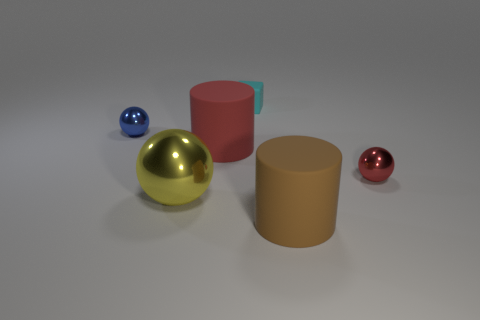Add 2 brown cylinders. How many objects exist? 8 Subtract all cubes. How many objects are left? 5 Subtract all large matte things. Subtract all red things. How many objects are left? 2 Add 6 large red cylinders. How many large red cylinders are left? 7 Add 6 red things. How many red things exist? 8 Subtract 0 gray spheres. How many objects are left? 6 